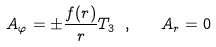Convert formula to latex. <formula><loc_0><loc_0><loc_500><loc_500>A _ { \varphi } = \pm \frac { f ( r ) } { r } T _ { 3 } \ , \quad A _ { r } = 0</formula> 